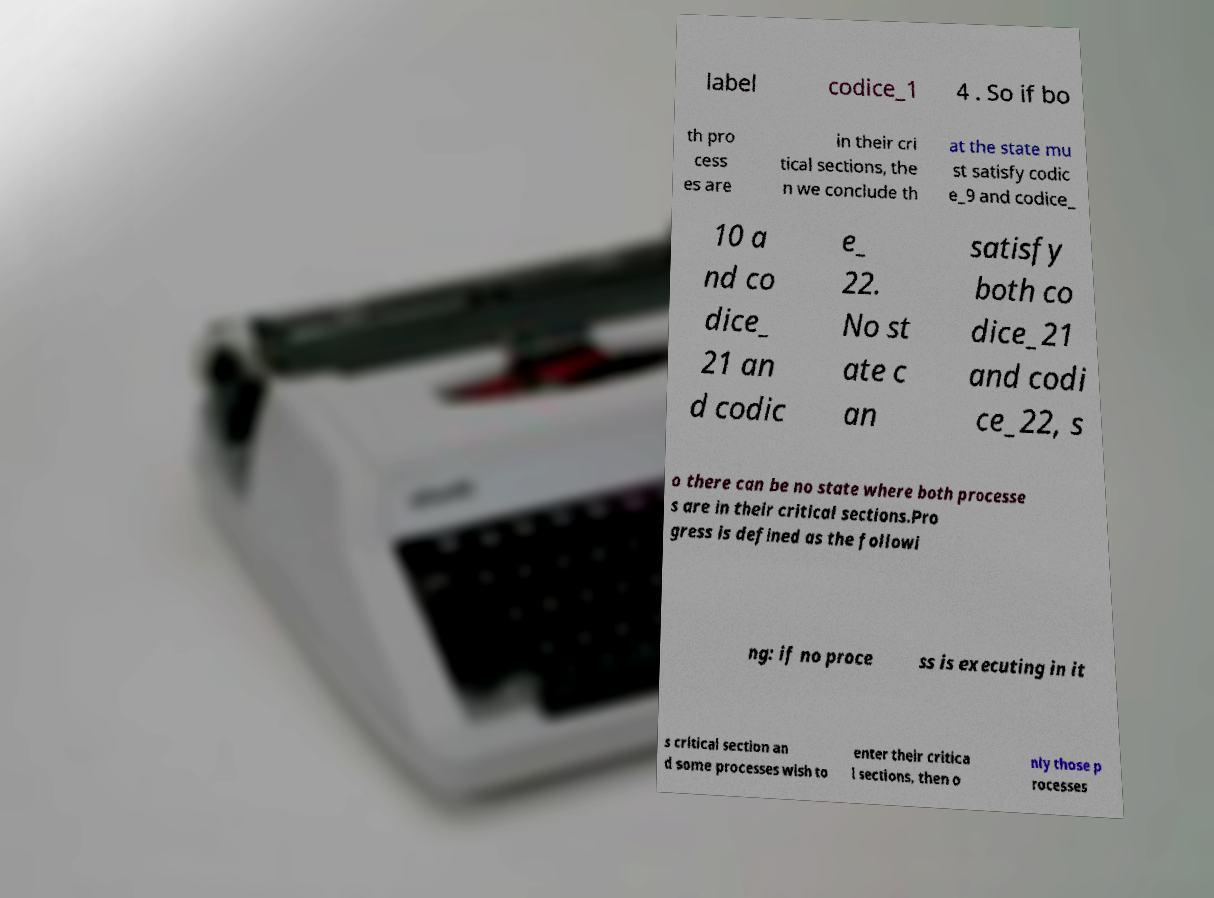Could you assist in decoding the text presented in this image and type it out clearly? label codice_1 4 . So if bo th pro cess es are in their cri tical sections, the n we conclude th at the state mu st satisfy codic e_9 and codice_ 10 a nd co dice_ 21 an d codic e_ 22. No st ate c an satisfy both co dice_21 and codi ce_22, s o there can be no state where both processe s are in their critical sections.Pro gress is defined as the followi ng: if no proce ss is executing in it s critical section an d some processes wish to enter their critica l sections, then o nly those p rocesses 